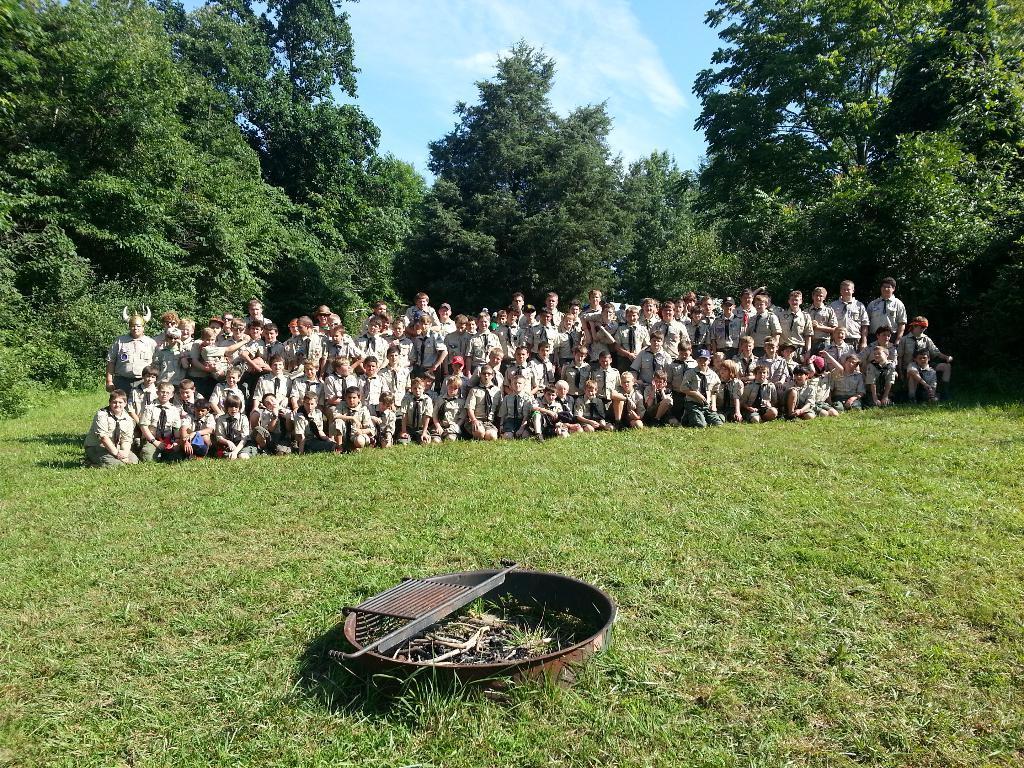Describe this image in one or two sentences. In this image we can see some people are arranged in rows, few are sitting and few are standing on the surface of the grass. At the bottom of the image there is a metal structure. In the background there are some trees and sky. 